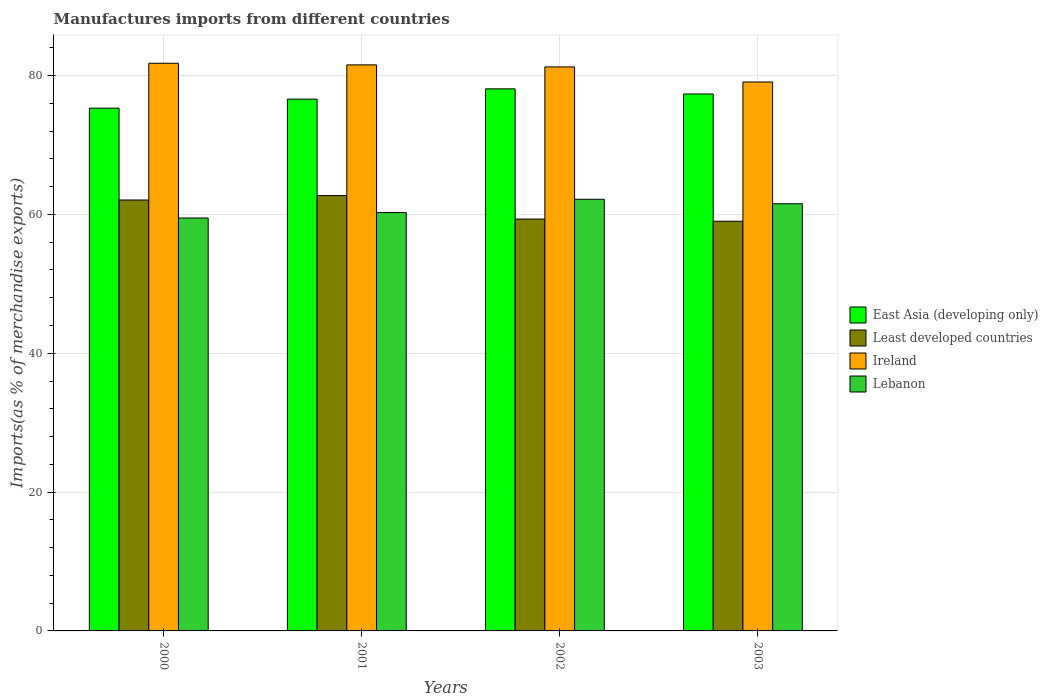How many groups of bars are there?
Ensure brevity in your answer.  4. Are the number of bars on each tick of the X-axis equal?
Your response must be concise. Yes. How many bars are there on the 4th tick from the left?
Offer a terse response. 4. How many bars are there on the 1st tick from the right?
Provide a short and direct response. 4. In how many cases, is the number of bars for a given year not equal to the number of legend labels?
Make the answer very short. 0. What is the percentage of imports to different countries in Ireland in 2001?
Offer a terse response. 81.55. Across all years, what is the maximum percentage of imports to different countries in East Asia (developing only)?
Your answer should be compact. 78.09. Across all years, what is the minimum percentage of imports to different countries in Lebanon?
Give a very brief answer. 59.49. In which year was the percentage of imports to different countries in Ireland maximum?
Your response must be concise. 2000. What is the total percentage of imports to different countries in Least developed countries in the graph?
Offer a terse response. 243.16. What is the difference between the percentage of imports to different countries in Least developed countries in 2000 and that in 2001?
Your response must be concise. -0.64. What is the difference between the percentage of imports to different countries in Ireland in 2000 and the percentage of imports to different countries in Least developed countries in 2002?
Make the answer very short. 22.44. What is the average percentage of imports to different countries in Ireland per year?
Keep it short and to the point. 80.92. In the year 2002, what is the difference between the percentage of imports to different countries in Lebanon and percentage of imports to different countries in Ireland?
Offer a terse response. -19.07. In how many years, is the percentage of imports to different countries in Least developed countries greater than 48 %?
Provide a succinct answer. 4. What is the ratio of the percentage of imports to different countries in Least developed countries in 2001 to that in 2002?
Keep it short and to the point. 1.06. Is the percentage of imports to different countries in Lebanon in 2001 less than that in 2002?
Provide a short and direct response. Yes. What is the difference between the highest and the second highest percentage of imports to different countries in East Asia (developing only)?
Make the answer very short. 0.74. What is the difference between the highest and the lowest percentage of imports to different countries in East Asia (developing only)?
Ensure brevity in your answer.  2.78. Is the sum of the percentage of imports to different countries in East Asia (developing only) in 2000 and 2003 greater than the maximum percentage of imports to different countries in Ireland across all years?
Give a very brief answer. Yes. What does the 4th bar from the left in 2000 represents?
Make the answer very short. Lebanon. What does the 1st bar from the right in 2002 represents?
Ensure brevity in your answer.  Lebanon. Is it the case that in every year, the sum of the percentage of imports to different countries in East Asia (developing only) and percentage of imports to different countries in Ireland is greater than the percentage of imports to different countries in Least developed countries?
Your response must be concise. Yes. How many bars are there?
Your answer should be compact. 16. Are all the bars in the graph horizontal?
Give a very brief answer. No. What is the difference between two consecutive major ticks on the Y-axis?
Your response must be concise. 20. Does the graph contain any zero values?
Provide a short and direct response. No. Does the graph contain grids?
Provide a succinct answer. Yes. What is the title of the graph?
Keep it short and to the point. Manufactures imports from different countries. What is the label or title of the X-axis?
Offer a very short reply. Years. What is the label or title of the Y-axis?
Provide a short and direct response. Imports(as % of merchandise exports). What is the Imports(as % of merchandise exports) of East Asia (developing only) in 2000?
Give a very brief answer. 75.31. What is the Imports(as % of merchandise exports) of Least developed countries in 2000?
Keep it short and to the point. 62.08. What is the Imports(as % of merchandise exports) in Ireland in 2000?
Your response must be concise. 81.78. What is the Imports(as % of merchandise exports) in Lebanon in 2000?
Give a very brief answer. 59.49. What is the Imports(as % of merchandise exports) in East Asia (developing only) in 2001?
Offer a very short reply. 76.61. What is the Imports(as % of merchandise exports) in Least developed countries in 2001?
Keep it short and to the point. 62.72. What is the Imports(as % of merchandise exports) of Ireland in 2001?
Make the answer very short. 81.55. What is the Imports(as % of merchandise exports) in Lebanon in 2001?
Offer a very short reply. 60.27. What is the Imports(as % of merchandise exports) of East Asia (developing only) in 2002?
Ensure brevity in your answer.  78.09. What is the Imports(as % of merchandise exports) in Least developed countries in 2002?
Keep it short and to the point. 59.34. What is the Imports(as % of merchandise exports) in Ireland in 2002?
Provide a succinct answer. 81.26. What is the Imports(as % of merchandise exports) in Lebanon in 2002?
Give a very brief answer. 62.19. What is the Imports(as % of merchandise exports) in East Asia (developing only) in 2003?
Make the answer very short. 77.36. What is the Imports(as % of merchandise exports) in Least developed countries in 2003?
Make the answer very short. 59.02. What is the Imports(as % of merchandise exports) of Ireland in 2003?
Provide a succinct answer. 79.08. What is the Imports(as % of merchandise exports) of Lebanon in 2003?
Offer a terse response. 61.54. Across all years, what is the maximum Imports(as % of merchandise exports) in East Asia (developing only)?
Your answer should be compact. 78.09. Across all years, what is the maximum Imports(as % of merchandise exports) in Least developed countries?
Offer a terse response. 62.72. Across all years, what is the maximum Imports(as % of merchandise exports) of Ireland?
Provide a succinct answer. 81.78. Across all years, what is the maximum Imports(as % of merchandise exports) of Lebanon?
Provide a short and direct response. 62.19. Across all years, what is the minimum Imports(as % of merchandise exports) of East Asia (developing only)?
Offer a very short reply. 75.31. Across all years, what is the minimum Imports(as % of merchandise exports) of Least developed countries?
Ensure brevity in your answer.  59.02. Across all years, what is the minimum Imports(as % of merchandise exports) of Ireland?
Provide a succinct answer. 79.08. Across all years, what is the minimum Imports(as % of merchandise exports) of Lebanon?
Your response must be concise. 59.49. What is the total Imports(as % of merchandise exports) of East Asia (developing only) in the graph?
Keep it short and to the point. 307.37. What is the total Imports(as % of merchandise exports) of Least developed countries in the graph?
Provide a succinct answer. 243.16. What is the total Imports(as % of merchandise exports) of Ireland in the graph?
Provide a succinct answer. 323.67. What is the total Imports(as % of merchandise exports) of Lebanon in the graph?
Provide a short and direct response. 243.49. What is the difference between the Imports(as % of merchandise exports) of East Asia (developing only) in 2000 and that in 2001?
Ensure brevity in your answer.  -1.3. What is the difference between the Imports(as % of merchandise exports) in Least developed countries in 2000 and that in 2001?
Keep it short and to the point. -0.64. What is the difference between the Imports(as % of merchandise exports) in Ireland in 2000 and that in 2001?
Ensure brevity in your answer.  0.24. What is the difference between the Imports(as % of merchandise exports) of Lebanon in 2000 and that in 2001?
Offer a very short reply. -0.78. What is the difference between the Imports(as % of merchandise exports) in East Asia (developing only) in 2000 and that in 2002?
Keep it short and to the point. -2.78. What is the difference between the Imports(as % of merchandise exports) in Least developed countries in 2000 and that in 2002?
Your answer should be compact. 2.74. What is the difference between the Imports(as % of merchandise exports) in Ireland in 2000 and that in 2002?
Offer a very short reply. 0.53. What is the difference between the Imports(as % of merchandise exports) in Lebanon in 2000 and that in 2002?
Provide a succinct answer. -2.7. What is the difference between the Imports(as % of merchandise exports) of East Asia (developing only) in 2000 and that in 2003?
Offer a very short reply. -2.05. What is the difference between the Imports(as % of merchandise exports) in Least developed countries in 2000 and that in 2003?
Provide a short and direct response. 3.06. What is the difference between the Imports(as % of merchandise exports) of Ireland in 2000 and that in 2003?
Offer a very short reply. 2.7. What is the difference between the Imports(as % of merchandise exports) of Lebanon in 2000 and that in 2003?
Provide a short and direct response. -2.05. What is the difference between the Imports(as % of merchandise exports) in East Asia (developing only) in 2001 and that in 2002?
Your answer should be very brief. -1.48. What is the difference between the Imports(as % of merchandise exports) in Least developed countries in 2001 and that in 2002?
Provide a short and direct response. 3.38. What is the difference between the Imports(as % of merchandise exports) in Ireland in 2001 and that in 2002?
Make the answer very short. 0.29. What is the difference between the Imports(as % of merchandise exports) in Lebanon in 2001 and that in 2002?
Make the answer very short. -1.92. What is the difference between the Imports(as % of merchandise exports) in East Asia (developing only) in 2001 and that in 2003?
Give a very brief answer. -0.74. What is the difference between the Imports(as % of merchandise exports) in Least developed countries in 2001 and that in 2003?
Provide a short and direct response. 3.7. What is the difference between the Imports(as % of merchandise exports) in Ireland in 2001 and that in 2003?
Ensure brevity in your answer.  2.46. What is the difference between the Imports(as % of merchandise exports) of Lebanon in 2001 and that in 2003?
Provide a short and direct response. -1.27. What is the difference between the Imports(as % of merchandise exports) in East Asia (developing only) in 2002 and that in 2003?
Give a very brief answer. 0.74. What is the difference between the Imports(as % of merchandise exports) of Least developed countries in 2002 and that in 2003?
Your response must be concise. 0.32. What is the difference between the Imports(as % of merchandise exports) of Ireland in 2002 and that in 2003?
Keep it short and to the point. 2.17. What is the difference between the Imports(as % of merchandise exports) in Lebanon in 2002 and that in 2003?
Make the answer very short. 0.65. What is the difference between the Imports(as % of merchandise exports) of East Asia (developing only) in 2000 and the Imports(as % of merchandise exports) of Least developed countries in 2001?
Ensure brevity in your answer.  12.59. What is the difference between the Imports(as % of merchandise exports) in East Asia (developing only) in 2000 and the Imports(as % of merchandise exports) in Ireland in 2001?
Ensure brevity in your answer.  -6.24. What is the difference between the Imports(as % of merchandise exports) of East Asia (developing only) in 2000 and the Imports(as % of merchandise exports) of Lebanon in 2001?
Make the answer very short. 15.04. What is the difference between the Imports(as % of merchandise exports) of Least developed countries in 2000 and the Imports(as % of merchandise exports) of Ireland in 2001?
Make the answer very short. -19.46. What is the difference between the Imports(as % of merchandise exports) in Least developed countries in 2000 and the Imports(as % of merchandise exports) in Lebanon in 2001?
Ensure brevity in your answer.  1.81. What is the difference between the Imports(as % of merchandise exports) of Ireland in 2000 and the Imports(as % of merchandise exports) of Lebanon in 2001?
Give a very brief answer. 21.51. What is the difference between the Imports(as % of merchandise exports) in East Asia (developing only) in 2000 and the Imports(as % of merchandise exports) in Least developed countries in 2002?
Your answer should be very brief. 15.97. What is the difference between the Imports(as % of merchandise exports) in East Asia (developing only) in 2000 and the Imports(as % of merchandise exports) in Ireland in 2002?
Keep it short and to the point. -5.94. What is the difference between the Imports(as % of merchandise exports) in East Asia (developing only) in 2000 and the Imports(as % of merchandise exports) in Lebanon in 2002?
Ensure brevity in your answer.  13.13. What is the difference between the Imports(as % of merchandise exports) in Least developed countries in 2000 and the Imports(as % of merchandise exports) in Ireland in 2002?
Your answer should be very brief. -19.17. What is the difference between the Imports(as % of merchandise exports) of Least developed countries in 2000 and the Imports(as % of merchandise exports) of Lebanon in 2002?
Offer a terse response. -0.1. What is the difference between the Imports(as % of merchandise exports) in Ireland in 2000 and the Imports(as % of merchandise exports) in Lebanon in 2002?
Offer a very short reply. 19.6. What is the difference between the Imports(as % of merchandise exports) in East Asia (developing only) in 2000 and the Imports(as % of merchandise exports) in Least developed countries in 2003?
Keep it short and to the point. 16.29. What is the difference between the Imports(as % of merchandise exports) in East Asia (developing only) in 2000 and the Imports(as % of merchandise exports) in Ireland in 2003?
Your answer should be compact. -3.77. What is the difference between the Imports(as % of merchandise exports) in East Asia (developing only) in 2000 and the Imports(as % of merchandise exports) in Lebanon in 2003?
Ensure brevity in your answer.  13.77. What is the difference between the Imports(as % of merchandise exports) in Least developed countries in 2000 and the Imports(as % of merchandise exports) in Ireland in 2003?
Provide a succinct answer. -17. What is the difference between the Imports(as % of merchandise exports) of Least developed countries in 2000 and the Imports(as % of merchandise exports) of Lebanon in 2003?
Ensure brevity in your answer.  0.54. What is the difference between the Imports(as % of merchandise exports) in Ireland in 2000 and the Imports(as % of merchandise exports) in Lebanon in 2003?
Your response must be concise. 20.24. What is the difference between the Imports(as % of merchandise exports) of East Asia (developing only) in 2001 and the Imports(as % of merchandise exports) of Least developed countries in 2002?
Keep it short and to the point. 17.27. What is the difference between the Imports(as % of merchandise exports) in East Asia (developing only) in 2001 and the Imports(as % of merchandise exports) in Ireland in 2002?
Keep it short and to the point. -4.64. What is the difference between the Imports(as % of merchandise exports) in East Asia (developing only) in 2001 and the Imports(as % of merchandise exports) in Lebanon in 2002?
Keep it short and to the point. 14.43. What is the difference between the Imports(as % of merchandise exports) in Least developed countries in 2001 and the Imports(as % of merchandise exports) in Ireland in 2002?
Provide a succinct answer. -18.54. What is the difference between the Imports(as % of merchandise exports) in Least developed countries in 2001 and the Imports(as % of merchandise exports) in Lebanon in 2002?
Keep it short and to the point. 0.53. What is the difference between the Imports(as % of merchandise exports) in Ireland in 2001 and the Imports(as % of merchandise exports) in Lebanon in 2002?
Your answer should be very brief. 19.36. What is the difference between the Imports(as % of merchandise exports) of East Asia (developing only) in 2001 and the Imports(as % of merchandise exports) of Least developed countries in 2003?
Provide a succinct answer. 17.59. What is the difference between the Imports(as % of merchandise exports) of East Asia (developing only) in 2001 and the Imports(as % of merchandise exports) of Ireland in 2003?
Your answer should be compact. -2.47. What is the difference between the Imports(as % of merchandise exports) of East Asia (developing only) in 2001 and the Imports(as % of merchandise exports) of Lebanon in 2003?
Provide a succinct answer. 15.07. What is the difference between the Imports(as % of merchandise exports) in Least developed countries in 2001 and the Imports(as % of merchandise exports) in Ireland in 2003?
Keep it short and to the point. -16.36. What is the difference between the Imports(as % of merchandise exports) in Least developed countries in 2001 and the Imports(as % of merchandise exports) in Lebanon in 2003?
Offer a very short reply. 1.18. What is the difference between the Imports(as % of merchandise exports) of Ireland in 2001 and the Imports(as % of merchandise exports) of Lebanon in 2003?
Your answer should be very brief. 20.01. What is the difference between the Imports(as % of merchandise exports) in East Asia (developing only) in 2002 and the Imports(as % of merchandise exports) in Least developed countries in 2003?
Keep it short and to the point. 19.07. What is the difference between the Imports(as % of merchandise exports) of East Asia (developing only) in 2002 and the Imports(as % of merchandise exports) of Ireland in 2003?
Your answer should be very brief. -0.99. What is the difference between the Imports(as % of merchandise exports) in East Asia (developing only) in 2002 and the Imports(as % of merchandise exports) in Lebanon in 2003?
Keep it short and to the point. 16.55. What is the difference between the Imports(as % of merchandise exports) in Least developed countries in 2002 and the Imports(as % of merchandise exports) in Ireland in 2003?
Provide a succinct answer. -19.74. What is the difference between the Imports(as % of merchandise exports) of Least developed countries in 2002 and the Imports(as % of merchandise exports) of Lebanon in 2003?
Ensure brevity in your answer.  -2.2. What is the difference between the Imports(as % of merchandise exports) of Ireland in 2002 and the Imports(as % of merchandise exports) of Lebanon in 2003?
Give a very brief answer. 19.72. What is the average Imports(as % of merchandise exports) of East Asia (developing only) per year?
Keep it short and to the point. 76.84. What is the average Imports(as % of merchandise exports) in Least developed countries per year?
Ensure brevity in your answer.  60.79. What is the average Imports(as % of merchandise exports) of Ireland per year?
Your answer should be compact. 80.92. What is the average Imports(as % of merchandise exports) of Lebanon per year?
Your answer should be compact. 60.87. In the year 2000, what is the difference between the Imports(as % of merchandise exports) of East Asia (developing only) and Imports(as % of merchandise exports) of Least developed countries?
Give a very brief answer. 13.23. In the year 2000, what is the difference between the Imports(as % of merchandise exports) in East Asia (developing only) and Imports(as % of merchandise exports) in Ireland?
Ensure brevity in your answer.  -6.47. In the year 2000, what is the difference between the Imports(as % of merchandise exports) in East Asia (developing only) and Imports(as % of merchandise exports) in Lebanon?
Keep it short and to the point. 15.82. In the year 2000, what is the difference between the Imports(as % of merchandise exports) in Least developed countries and Imports(as % of merchandise exports) in Ireland?
Provide a succinct answer. -19.7. In the year 2000, what is the difference between the Imports(as % of merchandise exports) of Least developed countries and Imports(as % of merchandise exports) of Lebanon?
Make the answer very short. 2.59. In the year 2000, what is the difference between the Imports(as % of merchandise exports) in Ireland and Imports(as % of merchandise exports) in Lebanon?
Make the answer very short. 22.29. In the year 2001, what is the difference between the Imports(as % of merchandise exports) of East Asia (developing only) and Imports(as % of merchandise exports) of Least developed countries?
Your answer should be compact. 13.89. In the year 2001, what is the difference between the Imports(as % of merchandise exports) of East Asia (developing only) and Imports(as % of merchandise exports) of Ireland?
Offer a very short reply. -4.93. In the year 2001, what is the difference between the Imports(as % of merchandise exports) of East Asia (developing only) and Imports(as % of merchandise exports) of Lebanon?
Keep it short and to the point. 16.34. In the year 2001, what is the difference between the Imports(as % of merchandise exports) in Least developed countries and Imports(as % of merchandise exports) in Ireland?
Give a very brief answer. -18.83. In the year 2001, what is the difference between the Imports(as % of merchandise exports) of Least developed countries and Imports(as % of merchandise exports) of Lebanon?
Your response must be concise. 2.45. In the year 2001, what is the difference between the Imports(as % of merchandise exports) of Ireland and Imports(as % of merchandise exports) of Lebanon?
Provide a succinct answer. 21.28. In the year 2002, what is the difference between the Imports(as % of merchandise exports) in East Asia (developing only) and Imports(as % of merchandise exports) in Least developed countries?
Provide a succinct answer. 18.76. In the year 2002, what is the difference between the Imports(as % of merchandise exports) in East Asia (developing only) and Imports(as % of merchandise exports) in Ireland?
Provide a short and direct response. -3.16. In the year 2002, what is the difference between the Imports(as % of merchandise exports) of East Asia (developing only) and Imports(as % of merchandise exports) of Lebanon?
Your answer should be very brief. 15.91. In the year 2002, what is the difference between the Imports(as % of merchandise exports) in Least developed countries and Imports(as % of merchandise exports) in Ireland?
Provide a short and direct response. -21.92. In the year 2002, what is the difference between the Imports(as % of merchandise exports) of Least developed countries and Imports(as % of merchandise exports) of Lebanon?
Offer a terse response. -2.85. In the year 2002, what is the difference between the Imports(as % of merchandise exports) in Ireland and Imports(as % of merchandise exports) in Lebanon?
Ensure brevity in your answer.  19.07. In the year 2003, what is the difference between the Imports(as % of merchandise exports) of East Asia (developing only) and Imports(as % of merchandise exports) of Least developed countries?
Give a very brief answer. 18.33. In the year 2003, what is the difference between the Imports(as % of merchandise exports) in East Asia (developing only) and Imports(as % of merchandise exports) in Ireland?
Offer a terse response. -1.73. In the year 2003, what is the difference between the Imports(as % of merchandise exports) of East Asia (developing only) and Imports(as % of merchandise exports) of Lebanon?
Provide a succinct answer. 15.82. In the year 2003, what is the difference between the Imports(as % of merchandise exports) of Least developed countries and Imports(as % of merchandise exports) of Ireland?
Keep it short and to the point. -20.06. In the year 2003, what is the difference between the Imports(as % of merchandise exports) of Least developed countries and Imports(as % of merchandise exports) of Lebanon?
Keep it short and to the point. -2.52. In the year 2003, what is the difference between the Imports(as % of merchandise exports) in Ireland and Imports(as % of merchandise exports) in Lebanon?
Offer a terse response. 17.54. What is the ratio of the Imports(as % of merchandise exports) in Least developed countries in 2000 to that in 2001?
Your answer should be compact. 0.99. What is the ratio of the Imports(as % of merchandise exports) in Ireland in 2000 to that in 2001?
Ensure brevity in your answer.  1. What is the ratio of the Imports(as % of merchandise exports) in East Asia (developing only) in 2000 to that in 2002?
Provide a short and direct response. 0.96. What is the ratio of the Imports(as % of merchandise exports) of Least developed countries in 2000 to that in 2002?
Offer a terse response. 1.05. What is the ratio of the Imports(as % of merchandise exports) in Ireland in 2000 to that in 2002?
Provide a short and direct response. 1.01. What is the ratio of the Imports(as % of merchandise exports) of Lebanon in 2000 to that in 2002?
Make the answer very short. 0.96. What is the ratio of the Imports(as % of merchandise exports) of East Asia (developing only) in 2000 to that in 2003?
Give a very brief answer. 0.97. What is the ratio of the Imports(as % of merchandise exports) of Least developed countries in 2000 to that in 2003?
Offer a terse response. 1.05. What is the ratio of the Imports(as % of merchandise exports) of Ireland in 2000 to that in 2003?
Your answer should be compact. 1.03. What is the ratio of the Imports(as % of merchandise exports) of Lebanon in 2000 to that in 2003?
Your answer should be very brief. 0.97. What is the ratio of the Imports(as % of merchandise exports) of East Asia (developing only) in 2001 to that in 2002?
Offer a terse response. 0.98. What is the ratio of the Imports(as % of merchandise exports) of Least developed countries in 2001 to that in 2002?
Provide a short and direct response. 1.06. What is the ratio of the Imports(as % of merchandise exports) in Lebanon in 2001 to that in 2002?
Offer a terse response. 0.97. What is the ratio of the Imports(as % of merchandise exports) in East Asia (developing only) in 2001 to that in 2003?
Give a very brief answer. 0.99. What is the ratio of the Imports(as % of merchandise exports) of Least developed countries in 2001 to that in 2003?
Provide a short and direct response. 1.06. What is the ratio of the Imports(as % of merchandise exports) of Ireland in 2001 to that in 2003?
Ensure brevity in your answer.  1.03. What is the ratio of the Imports(as % of merchandise exports) of Lebanon in 2001 to that in 2003?
Offer a very short reply. 0.98. What is the ratio of the Imports(as % of merchandise exports) of East Asia (developing only) in 2002 to that in 2003?
Provide a short and direct response. 1.01. What is the ratio of the Imports(as % of merchandise exports) in Least developed countries in 2002 to that in 2003?
Give a very brief answer. 1.01. What is the ratio of the Imports(as % of merchandise exports) of Ireland in 2002 to that in 2003?
Provide a succinct answer. 1.03. What is the ratio of the Imports(as % of merchandise exports) in Lebanon in 2002 to that in 2003?
Keep it short and to the point. 1.01. What is the difference between the highest and the second highest Imports(as % of merchandise exports) in East Asia (developing only)?
Make the answer very short. 0.74. What is the difference between the highest and the second highest Imports(as % of merchandise exports) in Least developed countries?
Your answer should be compact. 0.64. What is the difference between the highest and the second highest Imports(as % of merchandise exports) in Ireland?
Offer a very short reply. 0.24. What is the difference between the highest and the second highest Imports(as % of merchandise exports) of Lebanon?
Offer a very short reply. 0.65. What is the difference between the highest and the lowest Imports(as % of merchandise exports) of East Asia (developing only)?
Provide a succinct answer. 2.78. What is the difference between the highest and the lowest Imports(as % of merchandise exports) in Least developed countries?
Offer a terse response. 3.7. What is the difference between the highest and the lowest Imports(as % of merchandise exports) in Ireland?
Provide a short and direct response. 2.7. What is the difference between the highest and the lowest Imports(as % of merchandise exports) in Lebanon?
Your answer should be compact. 2.7. 